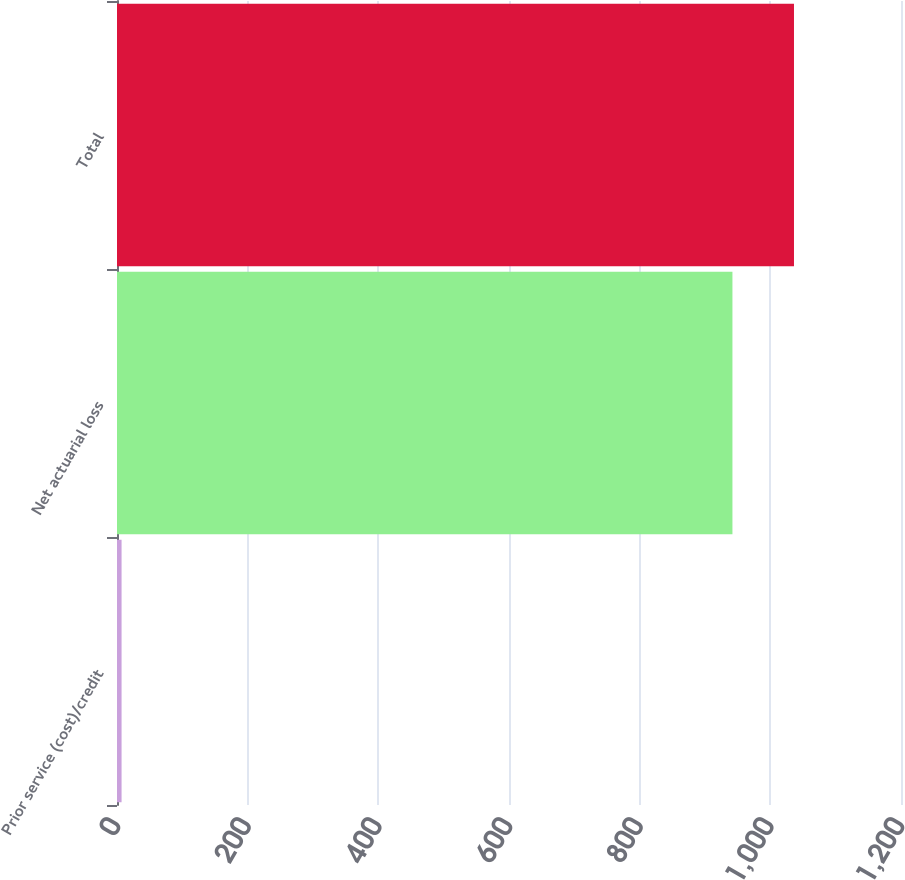Convert chart to OTSL. <chart><loc_0><loc_0><loc_500><loc_500><bar_chart><fcel>Prior service (cost)/credit<fcel>Net actuarial loss<fcel>Total<nl><fcel>7<fcel>942<fcel>1036.2<nl></chart> 